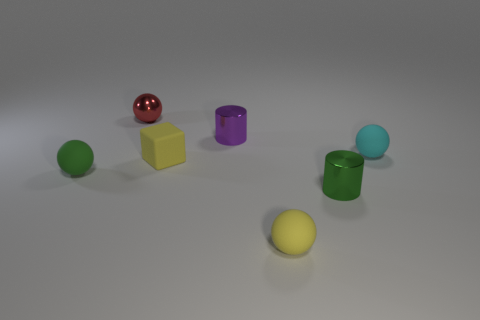Add 1 yellow blocks. How many objects exist? 8 Subtract all tiny green balls. How many balls are left? 3 Subtract all green cylinders. How many cylinders are left? 1 Subtract 1 cubes. How many cubes are left? 0 Subtract all cylinders. How many objects are left? 5 Subtract all yellow spheres. Subtract all yellow cylinders. How many spheres are left? 3 Subtract all blue balls. How many red blocks are left? 0 Subtract all blue shiny blocks. Subtract all tiny yellow matte blocks. How many objects are left? 6 Add 6 small green balls. How many small green balls are left? 7 Add 6 large blue matte objects. How many large blue matte objects exist? 6 